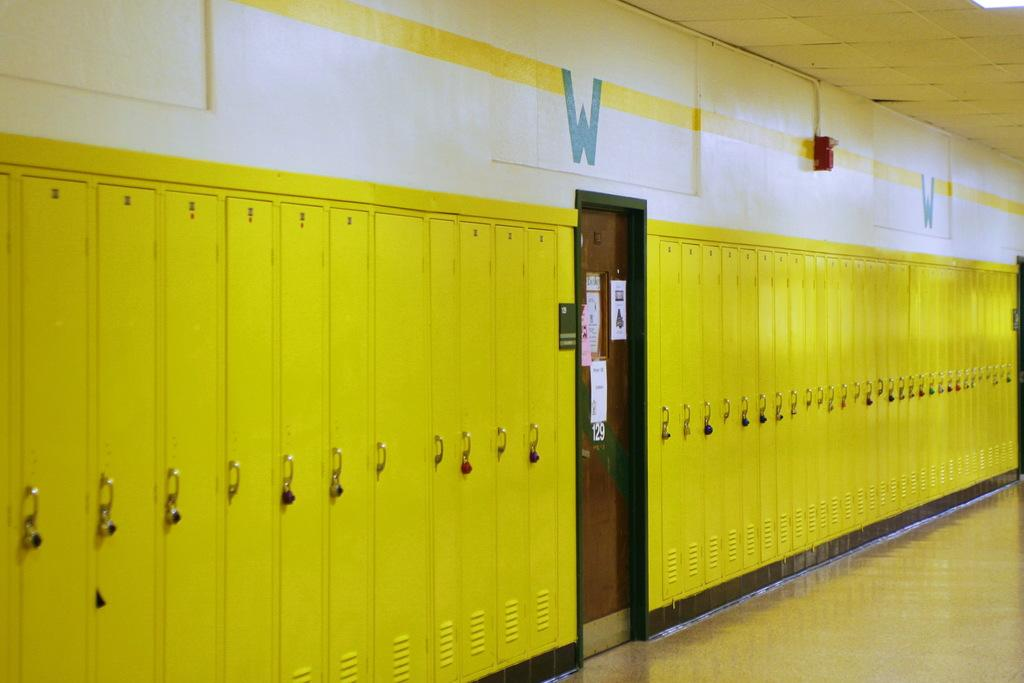What is on the wall in the image? There is a wall with locks in the image. What is the purpose of the door in the image? The door is likely for entering or exiting the space. What type of decorations are present in the image? There are posters in the image. What is attached to the wall in the image? There is an object attached to the wall in the image. What can be seen below the wall in the image? The ground is visible in the image. What is visible above the wall in the image? The roof is visible in the image. Can you see a cake on the roof in the image? There is no cake present in the image, and the roof is not mentioned as having any objects on it. Are there any feathers visible on the ground in the image? There is no mention of feathers in the image, so we cannot determine if any are present. 